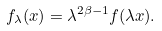Convert formula to latex. <formula><loc_0><loc_0><loc_500><loc_500>f _ { \lambda } ( x ) = \lambda ^ { 2 \beta - 1 } f ( \lambda x ) .</formula> 